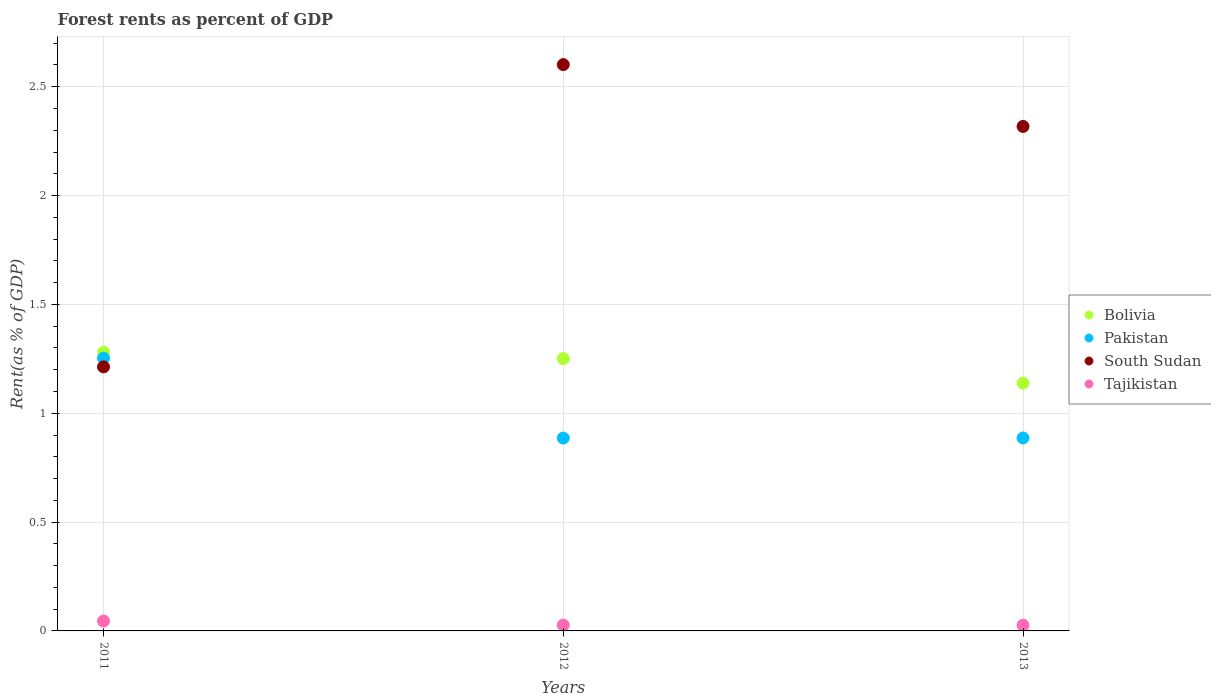How many different coloured dotlines are there?
Your answer should be very brief. 4. Is the number of dotlines equal to the number of legend labels?
Your answer should be very brief. Yes. What is the forest rent in Bolivia in 2011?
Keep it short and to the point. 1.28. Across all years, what is the maximum forest rent in South Sudan?
Your answer should be very brief. 2.6. Across all years, what is the minimum forest rent in Bolivia?
Offer a very short reply. 1.14. In which year was the forest rent in South Sudan maximum?
Your answer should be very brief. 2012. In which year was the forest rent in Pakistan minimum?
Your response must be concise. 2012. What is the total forest rent in Tajikistan in the graph?
Make the answer very short. 0.1. What is the difference between the forest rent in South Sudan in 2012 and that in 2013?
Your response must be concise. 0.28. What is the difference between the forest rent in South Sudan in 2011 and the forest rent in Bolivia in 2013?
Your answer should be very brief. 0.07. What is the average forest rent in Pakistan per year?
Make the answer very short. 1.01. In the year 2012, what is the difference between the forest rent in Tajikistan and forest rent in Bolivia?
Your response must be concise. -1.22. In how many years, is the forest rent in Pakistan greater than 1.4 %?
Provide a short and direct response. 0. What is the ratio of the forest rent in Tajikistan in 2012 to that in 2013?
Offer a terse response. 1.02. Is the difference between the forest rent in Tajikistan in 2012 and 2013 greater than the difference between the forest rent in Bolivia in 2012 and 2013?
Provide a succinct answer. No. What is the difference between the highest and the second highest forest rent in Pakistan?
Make the answer very short. 0.37. What is the difference between the highest and the lowest forest rent in Bolivia?
Provide a short and direct response. 0.14. In how many years, is the forest rent in Bolivia greater than the average forest rent in Bolivia taken over all years?
Offer a very short reply. 2. Is the sum of the forest rent in Pakistan in 2011 and 2012 greater than the maximum forest rent in South Sudan across all years?
Give a very brief answer. No. Is it the case that in every year, the sum of the forest rent in Pakistan and forest rent in Tajikistan  is greater than the forest rent in South Sudan?
Ensure brevity in your answer.  No. Does the forest rent in Bolivia monotonically increase over the years?
Ensure brevity in your answer.  No. Is the forest rent in Bolivia strictly greater than the forest rent in Pakistan over the years?
Provide a short and direct response. Yes. Is the forest rent in Bolivia strictly less than the forest rent in Tajikistan over the years?
Make the answer very short. No. How many years are there in the graph?
Your response must be concise. 3. What is the difference between two consecutive major ticks on the Y-axis?
Provide a short and direct response. 0.5. Are the values on the major ticks of Y-axis written in scientific E-notation?
Give a very brief answer. No. Does the graph contain grids?
Your response must be concise. Yes. Where does the legend appear in the graph?
Offer a terse response. Center right. How many legend labels are there?
Make the answer very short. 4. What is the title of the graph?
Give a very brief answer. Forest rents as percent of GDP. Does "Guam" appear as one of the legend labels in the graph?
Make the answer very short. No. What is the label or title of the Y-axis?
Ensure brevity in your answer.  Rent(as % of GDP). What is the Rent(as % of GDP) of Bolivia in 2011?
Your response must be concise. 1.28. What is the Rent(as % of GDP) of Pakistan in 2011?
Your response must be concise. 1.25. What is the Rent(as % of GDP) of South Sudan in 2011?
Offer a terse response. 1.21. What is the Rent(as % of GDP) in Tajikistan in 2011?
Your answer should be very brief. 0.05. What is the Rent(as % of GDP) of Bolivia in 2012?
Give a very brief answer. 1.25. What is the Rent(as % of GDP) in Pakistan in 2012?
Provide a succinct answer. 0.89. What is the Rent(as % of GDP) of South Sudan in 2012?
Make the answer very short. 2.6. What is the Rent(as % of GDP) of Tajikistan in 2012?
Make the answer very short. 0.03. What is the Rent(as % of GDP) in Bolivia in 2013?
Ensure brevity in your answer.  1.14. What is the Rent(as % of GDP) of Pakistan in 2013?
Offer a very short reply. 0.89. What is the Rent(as % of GDP) in South Sudan in 2013?
Make the answer very short. 2.32. What is the Rent(as % of GDP) of Tajikistan in 2013?
Provide a short and direct response. 0.03. Across all years, what is the maximum Rent(as % of GDP) of Bolivia?
Offer a terse response. 1.28. Across all years, what is the maximum Rent(as % of GDP) in Pakistan?
Offer a terse response. 1.25. Across all years, what is the maximum Rent(as % of GDP) of South Sudan?
Give a very brief answer. 2.6. Across all years, what is the maximum Rent(as % of GDP) of Tajikistan?
Ensure brevity in your answer.  0.05. Across all years, what is the minimum Rent(as % of GDP) in Bolivia?
Offer a terse response. 1.14. Across all years, what is the minimum Rent(as % of GDP) in Pakistan?
Offer a terse response. 0.89. Across all years, what is the minimum Rent(as % of GDP) of South Sudan?
Offer a very short reply. 1.21. Across all years, what is the minimum Rent(as % of GDP) of Tajikistan?
Your response must be concise. 0.03. What is the total Rent(as % of GDP) in Bolivia in the graph?
Ensure brevity in your answer.  3.67. What is the total Rent(as % of GDP) of Pakistan in the graph?
Your answer should be very brief. 3.03. What is the total Rent(as % of GDP) of South Sudan in the graph?
Your response must be concise. 6.13. What is the total Rent(as % of GDP) in Tajikistan in the graph?
Provide a short and direct response. 0.1. What is the difference between the Rent(as % of GDP) in Bolivia in 2011 and that in 2012?
Offer a very short reply. 0.03. What is the difference between the Rent(as % of GDP) of Pakistan in 2011 and that in 2012?
Offer a very short reply. 0.37. What is the difference between the Rent(as % of GDP) of South Sudan in 2011 and that in 2012?
Your response must be concise. -1.39. What is the difference between the Rent(as % of GDP) in Tajikistan in 2011 and that in 2012?
Your answer should be very brief. 0.02. What is the difference between the Rent(as % of GDP) in Bolivia in 2011 and that in 2013?
Keep it short and to the point. 0.14. What is the difference between the Rent(as % of GDP) in Pakistan in 2011 and that in 2013?
Offer a very short reply. 0.37. What is the difference between the Rent(as % of GDP) of South Sudan in 2011 and that in 2013?
Your response must be concise. -1.1. What is the difference between the Rent(as % of GDP) in Tajikistan in 2011 and that in 2013?
Ensure brevity in your answer.  0.02. What is the difference between the Rent(as % of GDP) in Bolivia in 2012 and that in 2013?
Your answer should be very brief. 0.11. What is the difference between the Rent(as % of GDP) in Pakistan in 2012 and that in 2013?
Ensure brevity in your answer.  -0. What is the difference between the Rent(as % of GDP) in South Sudan in 2012 and that in 2013?
Keep it short and to the point. 0.28. What is the difference between the Rent(as % of GDP) of Tajikistan in 2012 and that in 2013?
Provide a succinct answer. 0. What is the difference between the Rent(as % of GDP) in Bolivia in 2011 and the Rent(as % of GDP) in Pakistan in 2012?
Your response must be concise. 0.39. What is the difference between the Rent(as % of GDP) of Bolivia in 2011 and the Rent(as % of GDP) of South Sudan in 2012?
Provide a succinct answer. -1.32. What is the difference between the Rent(as % of GDP) of Bolivia in 2011 and the Rent(as % of GDP) of Tajikistan in 2012?
Your answer should be very brief. 1.25. What is the difference between the Rent(as % of GDP) in Pakistan in 2011 and the Rent(as % of GDP) in South Sudan in 2012?
Keep it short and to the point. -1.35. What is the difference between the Rent(as % of GDP) of Pakistan in 2011 and the Rent(as % of GDP) of Tajikistan in 2012?
Provide a short and direct response. 1.23. What is the difference between the Rent(as % of GDP) of South Sudan in 2011 and the Rent(as % of GDP) of Tajikistan in 2012?
Your response must be concise. 1.19. What is the difference between the Rent(as % of GDP) in Bolivia in 2011 and the Rent(as % of GDP) in Pakistan in 2013?
Give a very brief answer. 0.39. What is the difference between the Rent(as % of GDP) of Bolivia in 2011 and the Rent(as % of GDP) of South Sudan in 2013?
Your answer should be compact. -1.04. What is the difference between the Rent(as % of GDP) in Bolivia in 2011 and the Rent(as % of GDP) in Tajikistan in 2013?
Keep it short and to the point. 1.25. What is the difference between the Rent(as % of GDP) of Pakistan in 2011 and the Rent(as % of GDP) of South Sudan in 2013?
Give a very brief answer. -1.06. What is the difference between the Rent(as % of GDP) in Pakistan in 2011 and the Rent(as % of GDP) in Tajikistan in 2013?
Offer a terse response. 1.23. What is the difference between the Rent(as % of GDP) in South Sudan in 2011 and the Rent(as % of GDP) in Tajikistan in 2013?
Your answer should be very brief. 1.19. What is the difference between the Rent(as % of GDP) of Bolivia in 2012 and the Rent(as % of GDP) of Pakistan in 2013?
Your answer should be compact. 0.36. What is the difference between the Rent(as % of GDP) in Bolivia in 2012 and the Rent(as % of GDP) in South Sudan in 2013?
Ensure brevity in your answer.  -1.07. What is the difference between the Rent(as % of GDP) of Bolivia in 2012 and the Rent(as % of GDP) of Tajikistan in 2013?
Give a very brief answer. 1.23. What is the difference between the Rent(as % of GDP) in Pakistan in 2012 and the Rent(as % of GDP) in South Sudan in 2013?
Give a very brief answer. -1.43. What is the difference between the Rent(as % of GDP) in Pakistan in 2012 and the Rent(as % of GDP) in Tajikistan in 2013?
Provide a succinct answer. 0.86. What is the difference between the Rent(as % of GDP) of South Sudan in 2012 and the Rent(as % of GDP) of Tajikistan in 2013?
Provide a short and direct response. 2.58. What is the average Rent(as % of GDP) of Bolivia per year?
Offer a terse response. 1.22. What is the average Rent(as % of GDP) in Pakistan per year?
Your response must be concise. 1.01. What is the average Rent(as % of GDP) of South Sudan per year?
Offer a very short reply. 2.04. What is the average Rent(as % of GDP) in Tajikistan per year?
Keep it short and to the point. 0.03. In the year 2011, what is the difference between the Rent(as % of GDP) in Bolivia and Rent(as % of GDP) in Pakistan?
Your answer should be compact. 0.03. In the year 2011, what is the difference between the Rent(as % of GDP) of Bolivia and Rent(as % of GDP) of South Sudan?
Provide a succinct answer. 0.07. In the year 2011, what is the difference between the Rent(as % of GDP) of Bolivia and Rent(as % of GDP) of Tajikistan?
Make the answer very short. 1.23. In the year 2011, what is the difference between the Rent(as % of GDP) of Pakistan and Rent(as % of GDP) of South Sudan?
Keep it short and to the point. 0.04. In the year 2011, what is the difference between the Rent(as % of GDP) of Pakistan and Rent(as % of GDP) of Tajikistan?
Your response must be concise. 1.21. In the year 2011, what is the difference between the Rent(as % of GDP) in South Sudan and Rent(as % of GDP) in Tajikistan?
Provide a succinct answer. 1.17. In the year 2012, what is the difference between the Rent(as % of GDP) in Bolivia and Rent(as % of GDP) in Pakistan?
Make the answer very short. 0.37. In the year 2012, what is the difference between the Rent(as % of GDP) in Bolivia and Rent(as % of GDP) in South Sudan?
Give a very brief answer. -1.35. In the year 2012, what is the difference between the Rent(as % of GDP) in Bolivia and Rent(as % of GDP) in Tajikistan?
Keep it short and to the point. 1.22. In the year 2012, what is the difference between the Rent(as % of GDP) of Pakistan and Rent(as % of GDP) of South Sudan?
Ensure brevity in your answer.  -1.72. In the year 2012, what is the difference between the Rent(as % of GDP) in Pakistan and Rent(as % of GDP) in Tajikistan?
Provide a short and direct response. 0.86. In the year 2012, what is the difference between the Rent(as % of GDP) in South Sudan and Rent(as % of GDP) in Tajikistan?
Ensure brevity in your answer.  2.57. In the year 2013, what is the difference between the Rent(as % of GDP) of Bolivia and Rent(as % of GDP) of Pakistan?
Offer a terse response. 0.25. In the year 2013, what is the difference between the Rent(as % of GDP) in Bolivia and Rent(as % of GDP) in South Sudan?
Make the answer very short. -1.18. In the year 2013, what is the difference between the Rent(as % of GDP) of Bolivia and Rent(as % of GDP) of Tajikistan?
Your answer should be compact. 1.11. In the year 2013, what is the difference between the Rent(as % of GDP) in Pakistan and Rent(as % of GDP) in South Sudan?
Give a very brief answer. -1.43. In the year 2013, what is the difference between the Rent(as % of GDP) of Pakistan and Rent(as % of GDP) of Tajikistan?
Give a very brief answer. 0.86. In the year 2013, what is the difference between the Rent(as % of GDP) of South Sudan and Rent(as % of GDP) of Tajikistan?
Provide a succinct answer. 2.29. What is the ratio of the Rent(as % of GDP) of Bolivia in 2011 to that in 2012?
Offer a very short reply. 1.02. What is the ratio of the Rent(as % of GDP) of Pakistan in 2011 to that in 2012?
Your answer should be very brief. 1.41. What is the ratio of the Rent(as % of GDP) of South Sudan in 2011 to that in 2012?
Your response must be concise. 0.47. What is the ratio of the Rent(as % of GDP) in Tajikistan in 2011 to that in 2012?
Your response must be concise. 1.68. What is the ratio of the Rent(as % of GDP) in Bolivia in 2011 to that in 2013?
Give a very brief answer. 1.12. What is the ratio of the Rent(as % of GDP) of Pakistan in 2011 to that in 2013?
Provide a short and direct response. 1.41. What is the ratio of the Rent(as % of GDP) in South Sudan in 2011 to that in 2013?
Ensure brevity in your answer.  0.52. What is the ratio of the Rent(as % of GDP) in Tajikistan in 2011 to that in 2013?
Give a very brief answer. 1.72. What is the ratio of the Rent(as % of GDP) of Bolivia in 2012 to that in 2013?
Give a very brief answer. 1.1. What is the ratio of the Rent(as % of GDP) in Pakistan in 2012 to that in 2013?
Ensure brevity in your answer.  1. What is the ratio of the Rent(as % of GDP) in South Sudan in 2012 to that in 2013?
Offer a terse response. 1.12. What is the ratio of the Rent(as % of GDP) of Tajikistan in 2012 to that in 2013?
Your response must be concise. 1.02. What is the difference between the highest and the second highest Rent(as % of GDP) of Bolivia?
Offer a very short reply. 0.03. What is the difference between the highest and the second highest Rent(as % of GDP) in Pakistan?
Give a very brief answer. 0.37. What is the difference between the highest and the second highest Rent(as % of GDP) of South Sudan?
Offer a very short reply. 0.28. What is the difference between the highest and the second highest Rent(as % of GDP) of Tajikistan?
Make the answer very short. 0.02. What is the difference between the highest and the lowest Rent(as % of GDP) in Bolivia?
Your response must be concise. 0.14. What is the difference between the highest and the lowest Rent(as % of GDP) in Pakistan?
Offer a terse response. 0.37. What is the difference between the highest and the lowest Rent(as % of GDP) in South Sudan?
Your answer should be compact. 1.39. What is the difference between the highest and the lowest Rent(as % of GDP) of Tajikistan?
Provide a succinct answer. 0.02. 